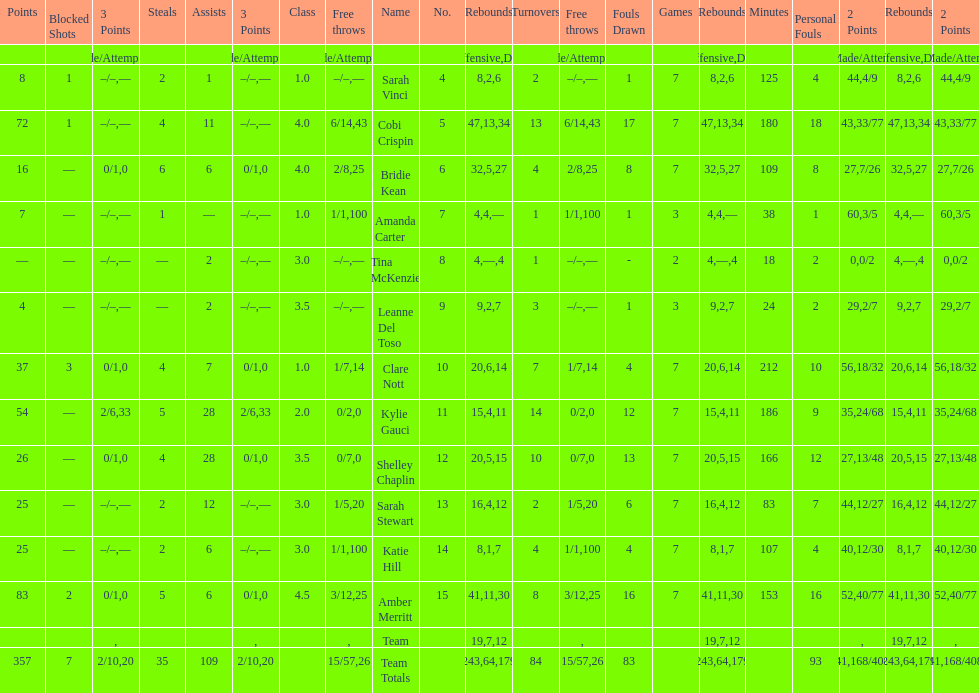Total number of assists and turnovers combined 193. 